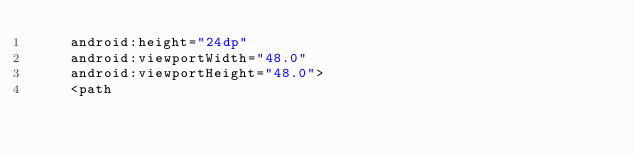<code> <loc_0><loc_0><loc_500><loc_500><_XML_>    android:height="24dp"
    android:viewportWidth="48.0"
    android:viewportHeight="48.0">
    <path</code> 